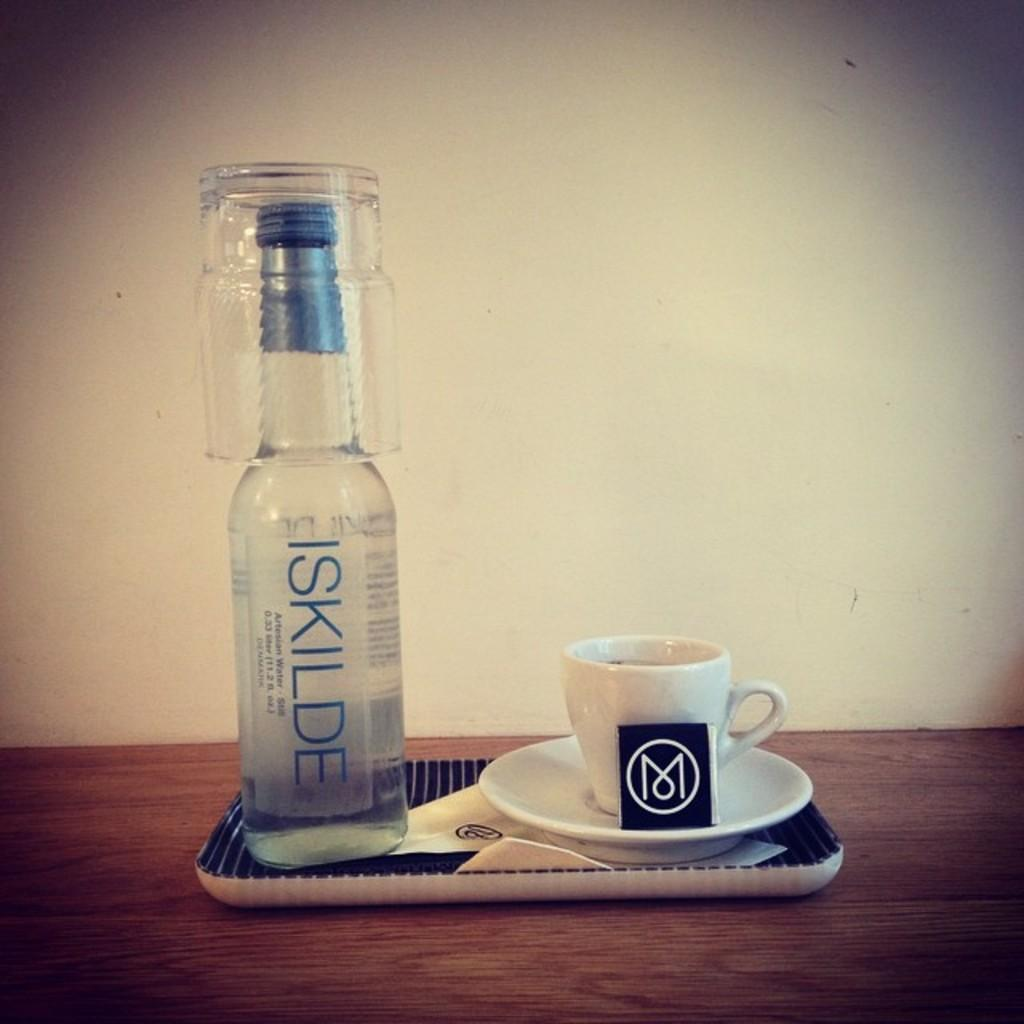Provide a one-sentence caption for the provided image. a bottle of iskilde with a cup resting on the top of the bottle. 